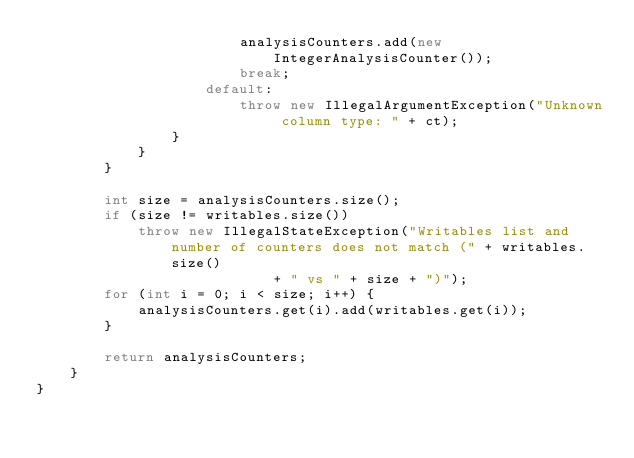Convert code to text. <code><loc_0><loc_0><loc_500><loc_500><_Java_>                        analysisCounters.add(new IntegerAnalysisCounter());
                        break;
                    default:
                        throw new IllegalArgumentException("Unknown column type: " + ct);
                }
            }
        }

        int size = analysisCounters.size();
        if (size != writables.size())
            throw new IllegalStateException("Writables list and number of counters does not match (" + writables.size()
                            + " vs " + size + ")");
        for (int i = 0; i < size; i++) {
            analysisCounters.get(i).add(writables.get(i));
        }

        return analysisCounters;
    }
}
</code> 